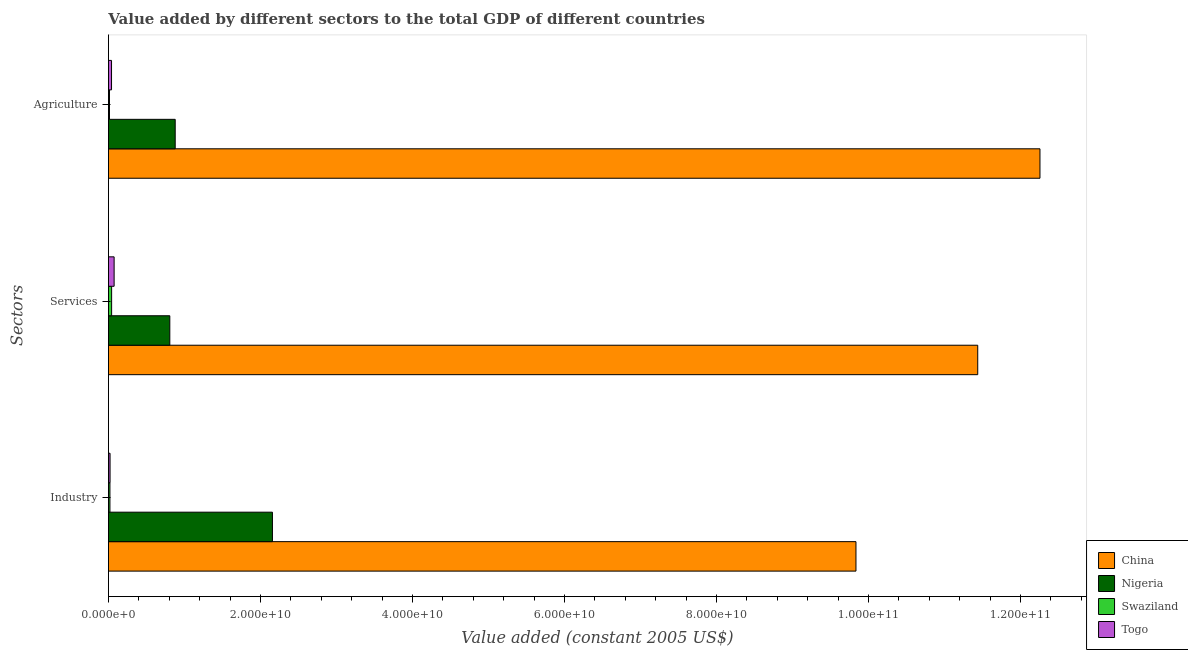How many different coloured bars are there?
Keep it short and to the point. 4. How many groups of bars are there?
Your answer should be compact. 3. Are the number of bars per tick equal to the number of legend labels?
Your response must be concise. Yes. How many bars are there on the 2nd tick from the bottom?
Provide a succinct answer. 4. What is the label of the 1st group of bars from the top?
Keep it short and to the point. Agriculture. What is the value added by agricultural sector in Nigeria?
Your answer should be very brief. 8.78e+09. Across all countries, what is the maximum value added by services?
Offer a terse response. 1.14e+11. Across all countries, what is the minimum value added by agricultural sector?
Offer a very short reply. 1.40e+08. In which country was the value added by agricultural sector maximum?
Offer a very short reply. China. In which country was the value added by agricultural sector minimum?
Offer a very short reply. Swaziland. What is the total value added by services in the graph?
Offer a terse response. 1.24e+11. What is the difference between the value added by industrial sector in Nigeria and that in China?
Give a very brief answer. -7.68e+1. What is the difference between the value added by services in China and the value added by agricultural sector in Togo?
Give a very brief answer. 1.14e+11. What is the average value added by services per country?
Your answer should be compact. 3.09e+1. What is the difference between the value added by industrial sector and value added by services in Swaziland?
Offer a very short reply. -2.20e+08. What is the ratio of the value added by services in Togo to that in Swaziland?
Offer a terse response. 1.79. Is the difference between the value added by agricultural sector in Swaziland and Togo greater than the difference between the value added by industrial sector in Swaziland and Togo?
Provide a short and direct response. No. What is the difference between the highest and the second highest value added by services?
Your answer should be compact. 1.06e+11. What is the difference between the highest and the lowest value added by services?
Make the answer very short. 1.14e+11. In how many countries, is the value added by services greater than the average value added by services taken over all countries?
Keep it short and to the point. 1. Is the sum of the value added by services in Togo and China greater than the maximum value added by agricultural sector across all countries?
Offer a very short reply. No. What does the 4th bar from the bottom in Industry represents?
Give a very brief answer. Togo. How many bars are there?
Provide a short and direct response. 12. Are all the bars in the graph horizontal?
Offer a very short reply. Yes. How many countries are there in the graph?
Your answer should be very brief. 4. What is the difference between two consecutive major ticks on the X-axis?
Provide a succinct answer. 2.00e+1. Are the values on the major ticks of X-axis written in scientific E-notation?
Give a very brief answer. Yes. Does the graph contain any zero values?
Provide a short and direct response. No. Does the graph contain grids?
Give a very brief answer. No. Where does the legend appear in the graph?
Offer a very short reply. Bottom right. How many legend labels are there?
Ensure brevity in your answer.  4. What is the title of the graph?
Make the answer very short. Value added by different sectors to the total GDP of different countries. Does "Korea (Republic)" appear as one of the legend labels in the graph?
Your answer should be compact. No. What is the label or title of the X-axis?
Give a very brief answer. Value added (constant 2005 US$). What is the label or title of the Y-axis?
Ensure brevity in your answer.  Sectors. What is the Value added (constant 2005 US$) in China in Industry?
Give a very brief answer. 9.84e+1. What is the Value added (constant 2005 US$) of Nigeria in Industry?
Your answer should be compact. 2.16e+1. What is the Value added (constant 2005 US$) in Swaziland in Industry?
Offer a very short reply. 1.99e+08. What is the Value added (constant 2005 US$) of Togo in Industry?
Make the answer very short. 2.14e+08. What is the Value added (constant 2005 US$) in China in Services?
Your answer should be very brief. 1.14e+11. What is the Value added (constant 2005 US$) in Nigeria in Services?
Your response must be concise. 8.08e+09. What is the Value added (constant 2005 US$) of Swaziland in Services?
Your answer should be compact. 4.19e+08. What is the Value added (constant 2005 US$) of Togo in Services?
Offer a very short reply. 7.50e+08. What is the Value added (constant 2005 US$) in China in Agriculture?
Offer a very short reply. 1.23e+11. What is the Value added (constant 2005 US$) in Nigeria in Agriculture?
Offer a very short reply. 8.78e+09. What is the Value added (constant 2005 US$) in Swaziland in Agriculture?
Make the answer very short. 1.40e+08. What is the Value added (constant 2005 US$) of Togo in Agriculture?
Offer a very short reply. 4.08e+08. Across all Sectors, what is the maximum Value added (constant 2005 US$) in China?
Offer a very short reply. 1.23e+11. Across all Sectors, what is the maximum Value added (constant 2005 US$) of Nigeria?
Keep it short and to the point. 2.16e+1. Across all Sectors, what is the maximum Value added (constant 2005 US$) in Swaziland?
Ensure brevity in your answer.  4.19e+08. Across all Sectors, what is the maximum Value added (constant 2005 US$) of Togo?
Offer a very short reply. 7.50e+08. Across all Sectors, what is the minimum Value added (constant 2005 US$) of China?
Ensure brevity in your answer.  9.84e+1. Across all Sectors, what is the minimum Value added (constant 2005 US$) of Nigeria?
Offer a terse response. 8.08e+09. Across all Sectors, what is the minimum Value added (constant 2005 US$) of Swaziland?
Your answer should be compact. 1.40e+08. Across all Sectors, what is the minimum Value added (constant 2005 US$) in Togo?
Offer a terse response. 2.14e+08. What is the total Value added (constant 2005 US$) of China in the graph?
Make the answer very short. 3.35e+11. What is the total Value added (constant 2005 US$) in Nigeria in the graph?
Give a very brief answer. 3.84e+1. What is the total Value added (constant 2005 US$) in Swaziland in the graph?
Make the answer very short. 7.58e+08. What is the total Value added (constant 2005 US$) in Togo in the graph?
Make the answer very short. 1.37e+09. What is the difference between the Value added (constant 2005 US$) in China in Industry and that in Services?
Offer a very short reply. -1.60e+1. What is the difference between the Value added (constant 2005 US$) of Nigeria in Industry and that in Services?
Give a very brief answer. 1.35e+1. What is the difference between the Value added (constant 2005 US$) of Swaziland in Industry and that in Services?
Offer a terse response. -2.20e+08. What is the difference between the Value added (constant 2005 US$) of Togo in Industry and that in Services?
Give a very brief answer. -5.36e+08. What is the difference between the Value added (constant 2005 US$) in China in Industry and that in Agriculture?
Your answer should be very brief. -2.42e+1. What is the difference between the Value added (constant 2005 US$) in Nigeria in Industry and that in Agriculture?
Your answer should be very brief. 1.28e+1. What is the difference between the Value added (constant 2005 US$) of Swaziland in Industry and that in Agriculture?
Your response must be concise. 5.96e+07. What is the difference between the Value added (constant 2005 US$) in Togo in Industry and that in Agriculture?
Provide a short and direct response. -1.94e+08. What is the difference between the Value added (constant 2005 US$) in China in Services and that in Agriculture?
Keep it short and to the point. -8.19e+09. What is the difference between the Value added (constant 2005 US$) in Nigeria in Services and that in Agriculture?
Provide a succinct answer. -7.07e+08. What is the difference between the Value added (constant 2005 US$) of Swaziland in Services and that in Agriculture?
Give a very brief answer. 2.80e+08. What is the difference between the Value added (constant 2005 US$) of Togo in Services and that in Agriculture?
Keep it short and to the point. 3.42e+08. What is the difference between the Value added (constant 2005 US$) of China in Industry and the Value added (constant 2005 US$) of Nigeria in Services?
Your response must be concise. 9.03e+1. What is the difference between the Value added (constant 2005 US$) of China in Industry and the Value added (constant 2005 US$) of Swaziland in Services?
Make the answer very short. 9.79e+1. What is the difference between the Value added (constant 2005 US$) of China in Industry and the Value added (constant 2005 US$) of Togo in Services?
Offer a very short reply. 9.76e+1. What is the difference between the Value added (constant 2005 US$) in Nigeria in Industry and the Value added (constant 2005 US$) in Swaziland in Services?
Provide a short and direct response. 2.12e+1. What is the difference between the Value added (constant 2005 US$) in Nigeria in Industry and the Value added (constant 2005 US$) in Togo in Services?
Provide a short and direct response. 2.08e+1. What is the difference between the Value added (constant 2005 US$) in Swaziland in Industry and the Value added (constant 2005 US$) in Togo in Services?
Provide a short and direct response. -5.50e+08. What is the difference between the Value added (constant 2005 US$) of China in Industry and the Value added (constant 2005 US$) of Nigeria in Agriculture?
Ensure brevity in your answer.  8.96e+1. What is the difference between the Value added (constant 2005 US$) of China in Industry and the Value added (constant 2005 US$) of Swaziland in Agriculture?
Give a very brief answer. 9.82e+1. What is the difference between the Value added (constant 2005 US$) of China in Industry and the Value added (constant 2005 US$) of Togo in Agriculture?
Provide a short and direct response. 9.79e+1. What is the difference between the Value added (constant 2005 US$) of Nigeria in Industry and the Value added (constant 2005 US$) of Swaziland in Agriculture?
Provide a succinct answer. 2.14e+1. What is the difference between the Value added (constant 2005 US$) in Nigeria in Industry and the Value added (constant 2005 US$) in Togo in Agriculture?
Ensure brevity in your answer.  2.12e+1. What is the difference between the Value added (constant 2005 US$) in Swaziland in Industry and the Value added (constant 2005 US$) in Togo in Agriculture?
Provide a short and direct response. -2.09e+08. What is the difference between the Value added (constant 2005 US$) of China in Services and the Value added (constant 2005 US$) of Nigeria in Agriculture?
Ensure brevity in your answer.  1.06e+11. What is the difference between the Value added (constant 2005 US$) in China in Services and the Value added (constant 2005 US$) in Swaziland in Agriculture?
Make the answer very short. 1.14e+11. What is the difference between the Value added (constant 2005 US$) in China in Services and the Value added (constant 2005 US$) in Togo in Agriculture?
Your answer should be compact. 1.14e+11. What is the difference between the Value added (constant 2005 US$) of Nigeria in Services and the Value added (constant 2005 US$) of Swaziland in Agriculture?
Give a very brief answer. 7.94e+09. What is the difference between the Value added (constant 2005 US$) of Nigeria in Services and the Value added (constant 2005 US$) of Togo in Agriculture?
Offer a very short reply. 7.67e+09. What is the difference between the Value added (constant 2005 US$) in Swaziland in Services and the Value added (constant 2005 US$) in Togo in Agriculture?
Provide a succinct answer. 1.15e+07. What is the average Value added (constant 2005 US$) in China per Sectors?
Ensure brevity in your answer.  1.12e+11. What is the average Value added (constant 2005 US$) of Nigeria per Sectors?
Ensure brevity in your answer.  1.28e+1. What is the average Value added (constant 2005 US$) in Swaziland per Sectors?
Offer a terse response. 2.53e+08. What is the average Value added (constant 2005 US$) in Togo per Sectors?
Provide a short and direct response. 4.57e+08. What is the difference between the Value added (constant 2005 US$) in China and Value added (constant 2005 US$) in Nigeria in Industry?
Give a very brief answer. 7.68e+1. What is the difference between the Value added (constant 2005 US$) of China and Value added (constant 2005 US$) of Swaziland in Industry?
Provide a succinct answer. 9.82e+1. What is the difference between the Value added (constant 2005 US$) of China and Value added (constant 2005 US$) of Togo in Industry?
Keep it short and to the point. 9.81e+1. What is the difference between the Value added (constant 2005 US$) in Nigeria and Value added (constant 2005 US$) in Swaziland in Industry?
Keep it short and to the point. 2.14e+1. What is the difference between the Value added (constant 2005 US$) in Nigeria and Value added (constant 2005 US$) in Togo in Industry?
Provide a short and direct response. 2.14e+1. What is the difference between the Value added (constant 2005 US$) in Swaziland and Value added (constant 2005 US$) in Togo in Industry?
Provide a succinct answer. -1.45e+07. What is the difference between the Value added (constant 2005 US$) in China and Value added (constant 2005 US$) in Nigeria in Services?
Keep it short and to the point. 1.06e+11. What is the difference between the Value added (constant 2005 US$) of China and Value added (constant 2005 US$) of Swaziland in Services?
Ensure brevity in your answer.  1.14e+11. What is the difference between the Value added (constant 2005 US$) in China and Value added (constant 2005 US$) in Togo in Services?
Provide a succinct answer. 1.14e+11. What is the difference between the Value added (constant 2005 US$) of Nigeria and Value added (constant 2005 US$) of Swaziland in Services?
Your answer should be very brief. 7.66e+09. What is the difference between the Value added (constant 2005 US$) in Nigeria and Value added (constant 2005 US$) in Togo in Services?
Ensure brevity in your answer.  7.33e+09. What is the difference between the Value added (constant 2005 US$) of Swaziland and Value added (constant 2005 US$) of Togo in Services?
Keep it short and to the point. -3.30e+08. What is the difference between the Value added (constant 2005 US$) of China and Value added (constant 2005 US$) of Nigeria in Agriculture?
Your answer should be compact. 1.14e+11. What is the difference between the Value added (constant 2005 US$) in China and Value added (constant 2005 US$) in Swaziland in Agriculture?
Keep it short and to the point. 1.22e+11. What is the difference between the Value added (constant 2005 US$) of China and Value added (constant 2005 US$) of Togo in Agriculture?
Keep it short and to the point. 1.22e+11. What is the difference between the Value added (constant 2005 US$) in Nigeria and Value added (constant 2005 US$) in Swaziland in Agriculture?
Offer a terse response. 8.64e+09. What is the difference between the Value added (constant 2005 US$) in Nigeria and Value added (constant 2005 US$) in Togo in Agriculture?
Your response must be concise. 8.38e+09. What is the difference between the Value added (constant 2005 US$) of Swaziland and Value added (constant 2005 US$) of Togo in Agriculture?
Your answer should be very brief. -2.68e+08. What is the ratio of the Value added (constant 2005 US$) of China in Industry to that in Services?
Your answer should be very brief. 0.86. What is the ratio of the Value added (constant 2005 US$) in Nigeria in Industry to that in Services?
Give a very brief answer. 2.67. What is the ratio of the Value added (constant 2005 US$) of Swaziland in Industry to that in Services?
Your response must be concise. 0.48. What is the ratio of the Value added (constant 2005 US$) in Togo in Industry to that in Services?
Ensure brevity in your answer.  0.29. What is the ratio of the Value added (constant 2005 US$) in China in Industry to that in Agriculture?
Your answer should be very brief. 0.8. What is the ratio of the Value added (constant 2005 US$) in Nigeria in Industry to that in Agriculture?
Provide a succinct answer. 2.46. What is the ratio of the Value added (constant 2005 US$) of Swaziland in Industry to that in Agriculture?
Give a very brief answer. 1.43. What is the ratio of the Value added (constant 2005 US$) of Togo in Industry to that in Agriculture?
Offer a terse response. 0.52. What is the ratio of the Value added (constant 2005 US$) of China in Services to that in Agriculture?
Offer a terse response. 0.93. What is the ratio of the Value added (constant 2005 US$) of Nigeria in Services to that in Agriculture?
Your answer should be compact. 0.92. What is the ratio of the Value added (constant 2005 US$) in Swaziland in Services to that in Agriculture?
Give a very brief answer. 3. What is the ratio of the Value added (constant 2005 US$) of Togo in Services to that in Agriculture?
Provide a short and direct response. 1.84. What is the difference between the highest and the second highest Value added (constant 2005 US$) of China?
Keep it short and to the point. 8.19e+09. What is the difference between the highest and the second highest Value added (constant 2005 US$) of Nigeria?
Ensure brevity in your answer.  1.28e+1. What is the difference between the highest and the second highest Value added (constant 2005 US$) in Swaziland?
Your response must be concise. 2.20e+08. What is the difference between the highest and the second highest Value added (constant 2005 US$) of Togo?
Ensure brevity in your answer.  3.42e+08. What is the difference between the highest and the lowest Value added (constant 2005 US$) in China?
Offer a very short reply. 2.42e+1. What is the difference between the highest and the lowest Value added (constant 2005 US$) in Nigeria?
Ensure brevity in your answer.  1.35e+1. What is the difference between the highest and the lowest Value added (constant 2005 US$) in Swaziland?
Ensure brevity in your answer.  2.80e+08. What is the difference between the highest and the lowest Value added (constant 2005 US$) of Togo?
Make the answer very short. 5.36e+08. 